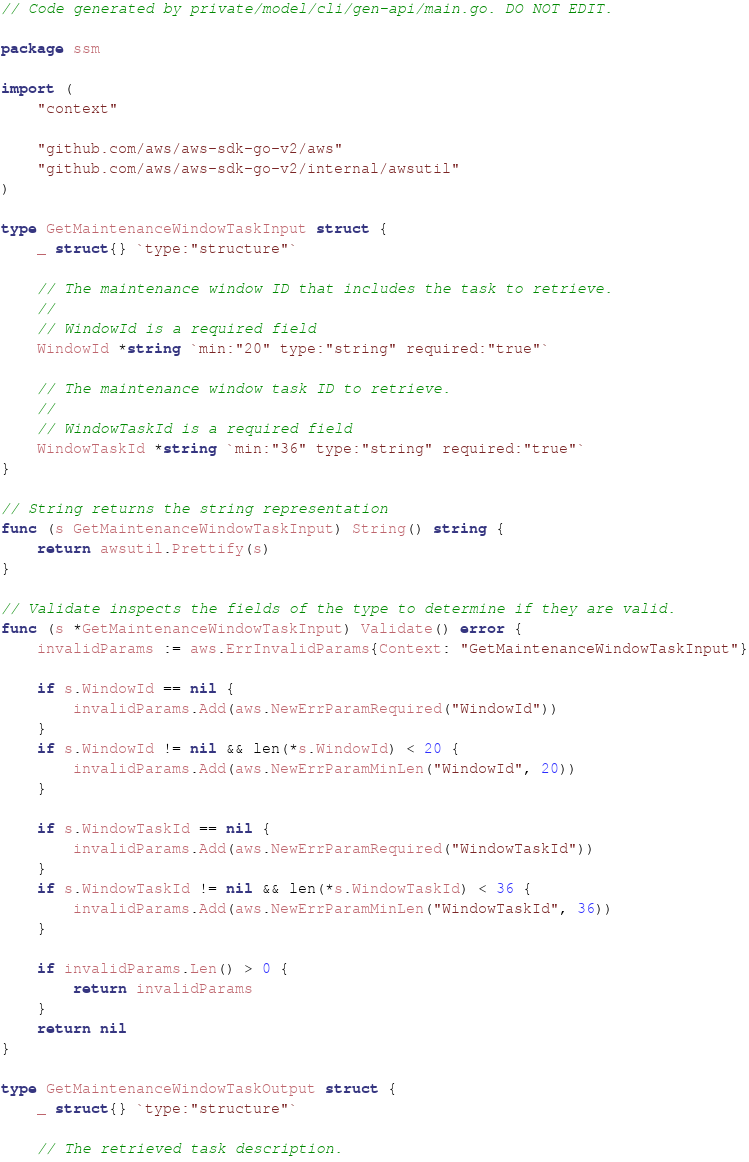Convert code to text. <code><loc_0><loc_0><loc_500><loc_500><_Go_>// Code generated by private/model/cli/gen-api/main.go. DO NOT EDIT.

package ssm

import (
	"context"

	"github.com/aws/aws-sdk-go-v2/aws"
	"github.com/aws/aws-sdk-go-v2/internal/awsutil"
)

type GetMaintenanceWindowTaskInput struct {
	_ struct{} `type:"structure"`

	// The maintenance window ID that includes the task to retrieve.
	//
	// WindowId is a required field
	WindowId *string `min:"20" type:"string" required:"true"`

	// The maintenance window task ID to retrieve.
	//
	// WindowTaskId is a required field
	WindowTaskId *string `min:"36" type:"string" required:"true"`
}

// String returns the string representation
func (s GetMaintenanceWindowTaskInput) String() string {
	return awsutil.Prettify(s)
}

// Validate inspects the fields of the type to determine if they are valid.
func (s *GetMaintenanceWindowTaskInput) Validate() error {
	invalidParams := aws.ErrInvalidParams{Context: "GetMaintenanceWindowTaskInput"}

	if s.WindowId == nil {
		invalidParams.Add(aws.NewErrParamRequired("WindowId"))
	}
	if s.WindowId != nil && len(*s.WindowId) < 20 {
		invalidParams.Add(aws.NewErrParamMinLen("WindowId", 20))
	}

	if s.WindowTaskId == nil {
		invalidParams.Add(aws.NewErrParamRequired("WindowTaskId"))
	}
	if s.WindowTaskId != nil && len(*s.WindowTaskId) < 36 {
		invalidParams.Add(aws.NewErrParamMinLen("WindowTaskId", 36))
	}

	if invalidParams.Len() > 0 {
		return invalidParams
	}
	return nil
}

type GetMaintenanceWindowTaskOutput struct {
	_ struct{} `type:"structure"`

	// The retrieved task description.</code> 